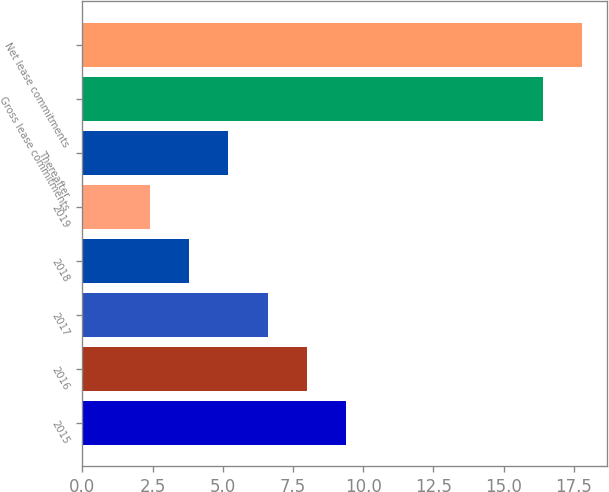<chart> <loc_0><loc_0><loc_500><loc_500><bar_chart><fcel>2015<fcel>2016<fcel>2017<fcel>2018<fcel>2019<fcel>Thereafter<fcel>Gross lease commitments<fcel>Net lease commitments<nl><fcel>9.4<fcel>8<fcel>6.6<fcel>3.8<fcel>2.4<fcel>5.2<fcel>16.4<fcel>17.8<nl></chart> 